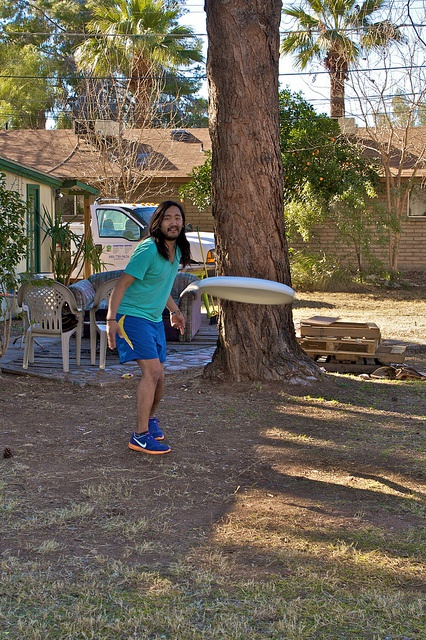Describe the objects in this image and their specific colors. I can see people in khaki, teal, brown, navy, and black tones, truck in khaki, darkgray, black, white, and tan tones, chair in khaki, gray, black, and darkgreen tones, frisbee in khaki, lightblue, tan, and gray tones, and chair in khaki, black, and gray tones in this image. 